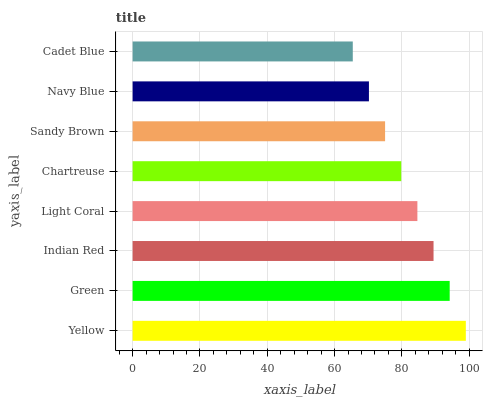Is Cadet Blue the minimum?
Answer yes or no. Yes. Is Yellow the maximum?
Answer yes or no. Yes. Is Green the minimum?
Answer yes or no. No. Is Green the maximum?
Answer yes or no. No. Is Yellow greater than Green?
Answer yes or no. Yes. Is Green less than Yellow?
Answer yes or no. Yes. Is Green greater than Yellow?
Answer yes or no. No. Is Yellow less than Green?
Answer yes or no. No. Is Light Coral the high median?
Answer yes or no. Yes. Is Chartreuse the low median?
Answer yes or no. Yes. Is Chartreuse the high median?
Answer yes or no. No. Is Navy Blue the low median?
Answer yes or no. No. 